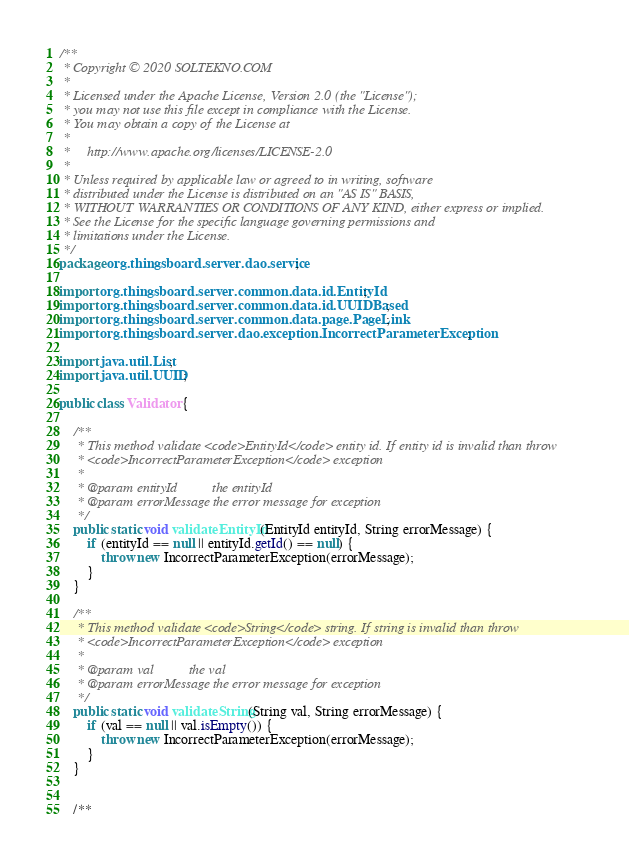<code> <loc_0><loc_0><loc_500><loc_500><_Java_>/**
 * Copyright © 2020 SOLTEKNO.COM
 *
 * Licensed under the Apache License, Version 2.0 (the "License");
 * you may not use this file except in compliance with the License.
 * You may obtain a copy of the License at
 *
 *     http://www.apache.org/licenses/LICENSE-2.0
 *
 * Unless required by applicable law or agreed to in writing, software
 * distributed under the License is distributed on an "AS IS" BASIS,
 * WITHOUT WARRANTIES OR CONDITIONS OF ANY KIND, either express or implied.
 * See the License for the specific language governing permissions and
 * limitations under the License.
 */
package org.thingsboard.server.dao.service;

import org.thingsboard.server.common.data.id.EntityId;
import org.thingsboard.server.common.data.id.UUIDBased;
import org.thingsboard.server.common.data.page.PageLink;
import org.thingsboard.server.dao.exception.IncorrectParameterException;

import java.util.List;
import java.util.UUID;

public class Validator {

    /**
     * This method validate <code>EntityId</code> entity id. If entity id is invalid than throw
     * <code>IncorrectParameterException</code> exception
     *
     * @param entityId          the entityId
     * @param errorMessage the error message for exception
     */
    public static void validateEntityId(EntityId entityId, String errorMessage) {
        if (entityId == null || entityId.getId() == null) {
            throw new IncorrectParameterException(errorMessage);
        }
    }

    /**
     * This method validate <code>String</code> string. If string is invalid than throw
     * <code>IncorrectParameterException</code> exception
     *
     * @param val          the val
     * @param errorMessage the error message for exception
     */
    public static void validateString(String val, String errorMessage) {
        if (val == null || val.isEmpty()) {
            throw new IncorrectParameterException(errorMessage);
        }
    }


    /**</code> 